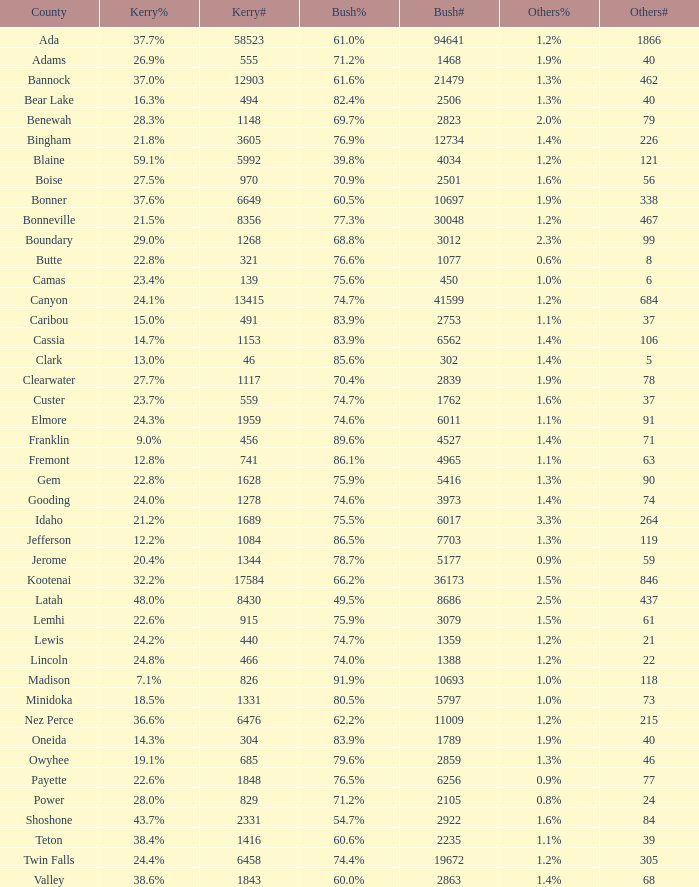What's percentage voted for Busg in the county where Kerry got 37.6%? 60.5%. 